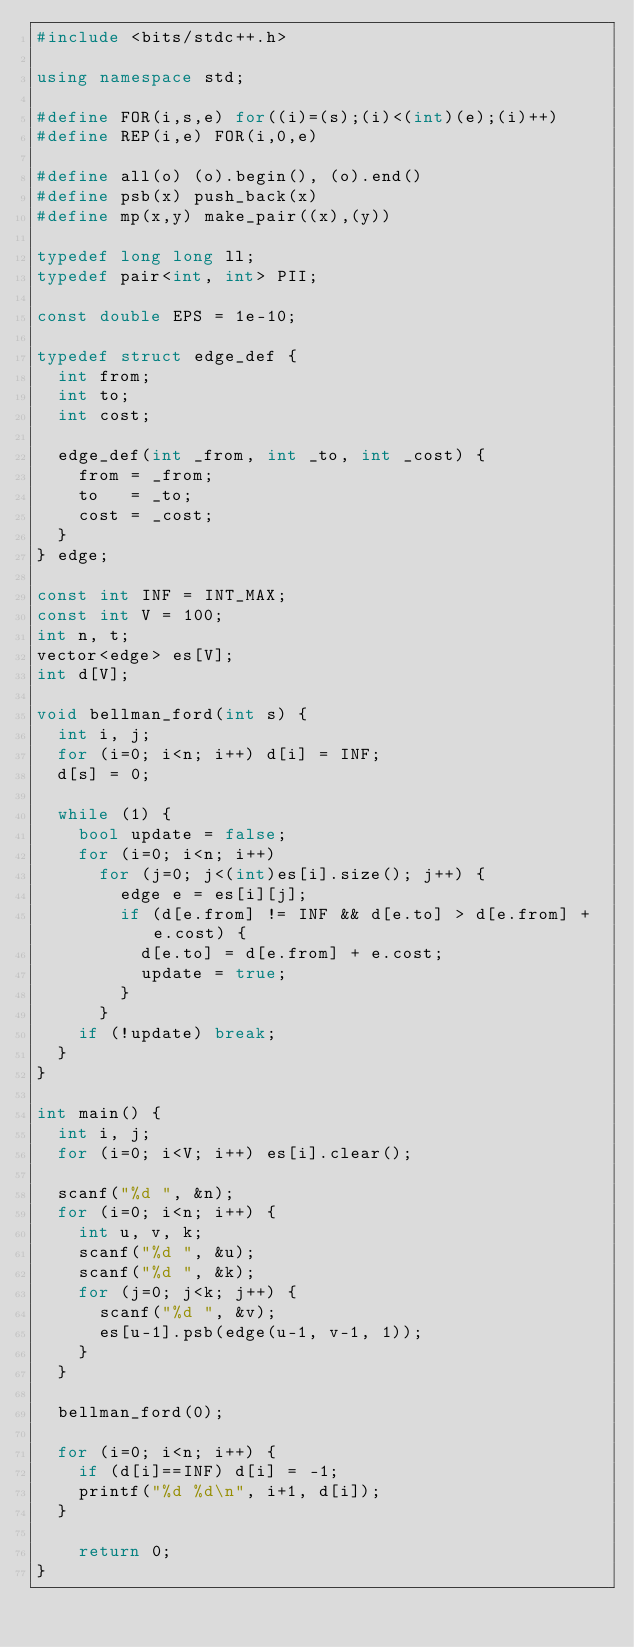<code> <loc_0><loc_0><loc_500><loc_500><_C++_>#include <bits/stdc++.h>

using namespace std;

#define FOR(i,s,e) for((i)=(s);(i)<(int)(e);(i)++)
#define REP(i,e) FOR(i,0,e)

#define all(o) (o).begin(), (o).end()
#define psb(x) push_back(x)
#define mp(x,y) make_pair((x),(y))

typedef long long ll;
typedef pair<int, int> PII;

const double EPS = 1e-10;

typedef struct edge_def {
  int from;
  int to;
  int cost;

  edge_def(int _from, int _to, int _cost) {
    from = _from;
    to   = _to;
    cost = _cost;
  }
} edge;

const int INF = INT_MAX;
const int V = 100;
int n, t;
vector<edge> es[V];
int d[V];

void bellman_ford(int s) {
  int i, j;
  for (i=0; i<n; i++) d[i] = INF;
  d[s] = 0;
  
  while (1) {
    bool update = false;
    for (i=0; i<n; i++)
      for (j=0; j<(int)es[i].size(); j++) {
        edge e = es[i][j];
        if (d[e.from] != INF && d[e.to] > d[e.from] + e.cost) {
          d[e.to] = d[e.from] + e.cost;
          update = true;
        }
      }
    if (!update) break;
  } 
}

int main() {
  int i, j;
  for (i=0; i<V; i++) es[i].clear();

  scanf("%d ", &n);
  for (i=0; i<n; i++) {
    int u, v, k;
    scanf("%d ", &u);
    scanf("%d ", &k);
    for (j=0; j<k; j++) {
      scanf("%d ", &v);
      es[u-1].psb(edge(u-1, v-1, 1));
    }
  }

  bellman_ford(0);

  for (i=0; i<n; i++) {
    if (d[i]==INF) d[i] = -1;
    printf("%d %d\n", i+1, d[i]);
  }

	return 0;
}</code> 